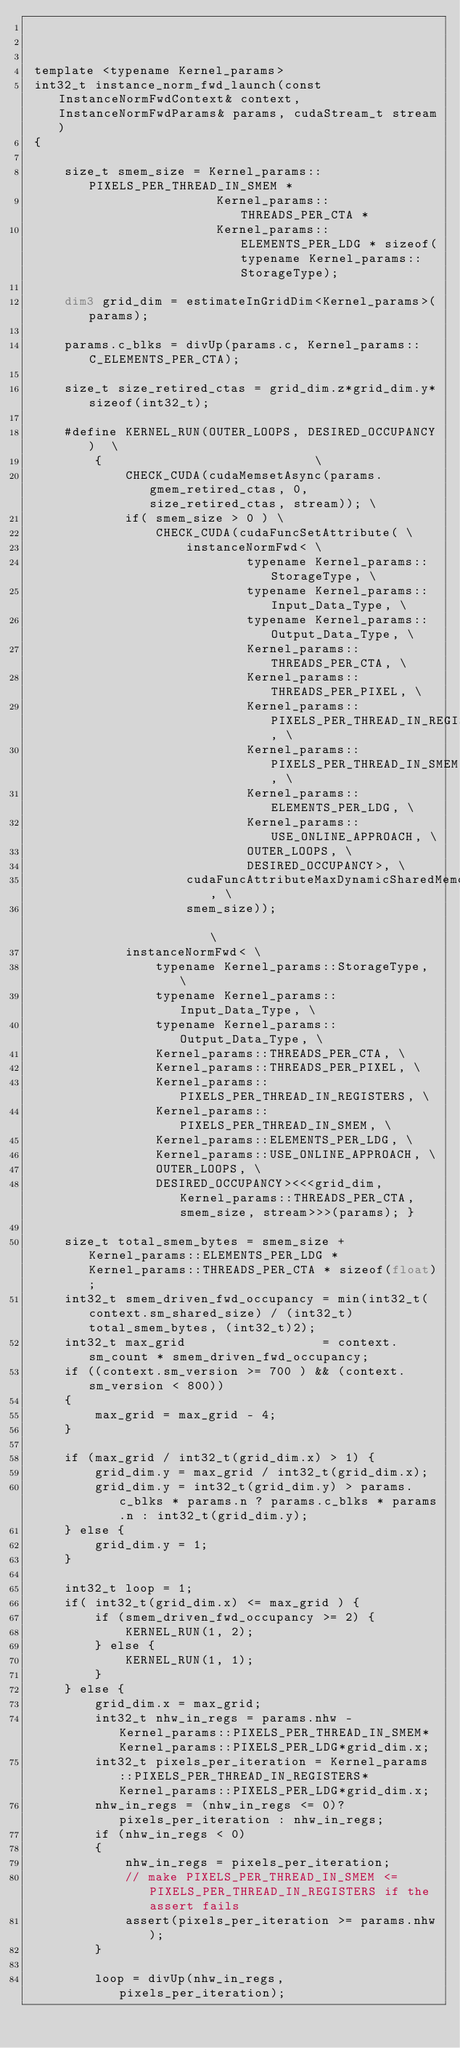Convert code to text. <code><loc_0><loc_0><loc_500><loc_500><_Cuda_>


 template <typename Kernel_params>
 int32_t instance_norm_fwd_launch(const InstanceNormFwdContext& context, InstanceNormFwdParams& params, cudaStream_t stream)
 {

     size_t smem_size = Kernel_params::PIXELS_PER_THREAD_IN_SMEM *
                         Kernel_params::THREADS_PER_CTA *
                         Kernel_params::ELEMENTS_PER_LDG * sizeof(typename Kernel_params::StorageType);

     dim3 grid_dim = estimateInGridDim<Kernel_params>(params);

     params.c_blks = divUp(params.c, Kernel_params::C_ELEMENTS_PER_CTA);

     size_t size_retired_ctas = grid_dim.z*grid_dim.y*sizeof(int32_t);

     #define KERNEL_RUN(OUTER_LOOPS, DESIRED_OCCUPANCY)  \
         {                            \
             CHECK_CUDA(cudaMemsetAsync(params.gmem_retired_ctas, 0, size_retired_ctas, stream)); \
             if( smem_size > 0 ) \
                 CHECK_CUDA(cudaFuncSetAttribute( \
                     instanceNormFwd< \
                             typename Kernel_params::StorageType, \
                             typename Kernel_params::Input_Data_Type, \
                             typename Kernel_params::Output_Data_Type, \
                             Kernel_params::THREADS_PER_CTA, \
                             Kernel_params::THREADS_PER_PIXEL, \
                             Kernel_params::PIXELS_PER_THREAD_IN_REGISTERS, \
                             Kernel_params::PIXELS_PER_THREAD_IN_SMEM, \
                             Kernel_params::ELEMENTS_PER_LDG, \
                             Kernel_params::USE_ONLINE_APPROACH, \
                             OUTER_LOOPS, \
                             DESIRED_OCCUPANCY>, \
                     cudaFuncAttributeMaxDynamicSharedMemorySize, \
                     smem_size));                                 \
             instanceNormFwd< \
                 typename Kernel_params::StorageType, \
                 typename Kernel_params::Input_Data_Type, \
                 typename Kernel_params::Output_Data_Type, \
                 Kernel_params::THREADS_PER_CTA, \
                 Kernel_params::THREADS_PER_PIXEL, \
                 Kernel_params::PIXELS_PER_THREAD_IN_REGISTERS, \
                 Kernel_params::PIXELS_PER_THREAD_IN_SMEM, \
                 Kernel_params::ELEMENTS_PER_LDG, \
                 Kernel_params::USE_ONLINE_APPROACH, \
                 OUTER_LOOPS, \
                 DESIRED_OCCUPANCY><<<grid_dim,Kernel_params::THREADS_PER_CTA, smem_size, stream>>>(params); }

     size_t total_smem_bytes = smem_size + Kernel_params::ELEMENTS_PER_LDG * Kernel_params::THREADS_PER_CTA * sizeof(float);
     int32_t smem_driven_fwd_occupancy = min(int32_t(context.sm_shared_size) / (int32_t)total_smem_bytes, (int32_t)2);
     int32_t max_grid                  = context.sm_count * smem_driven_fwd_occupancy;
     if ((context.sm_version >= 700 ) && (context.sm_version < 800))
     {
         max_grid = max_grid - 4;
     }

     if (max_grid / int32_t(grid_dim.x) > 1) {
         grid_dim.y = max_grid / int32_t(grid_dim.x);
         grid_dim.y = int32_t(grid_dim.y) > params.c_blks * params.n ? params.c_blks * params.n : int32_t(grid_dim.y);
     } else {
         grid_dim.y = 1;
     }

     int32_t loop = 1;
     if( int32_t(grid_dim.x) <= max_grid ) {
         if (smem_driven_fwd_occupancy >= 2) {
             KERNEL_RUN(1, 2);
         } else {
             KERNEL_RUN(1, 1);
         }
     } else {
         grid_dim.x = max_grid;
         int32_t nhw_in_regs = params.nhw - Kernel_params::PIXELS_PER_THREAD_IN_SMEM*Kernel_params::PIXELS_PER_LDG*grid_dim.x;
         int32_t pixels_per_iteration = Kernel_params::PIXELS_PER_THREAD_IN_REGISTERS*Kernel_params::PIXELS_PER_LDG*grid_dim.x;
         nhw_in_regs = (nhw_in_regs <= 0)? pixels_per_iteration : nhw_in_regs;
         if (nhw_in_regs < 0)
         {
             nhw_in_regs = pixels_per_iteration;
             // make PIXELS_PER_THREAD_IN_SMEM <= PIXELS_PER_THREAD_IN_REGISTERS if the assert fails
             assert(pixels_per_iteration >= params.nhw);
         }

         loop = divUp(nhw_in_regs, pixels_per_iteration);</code> 